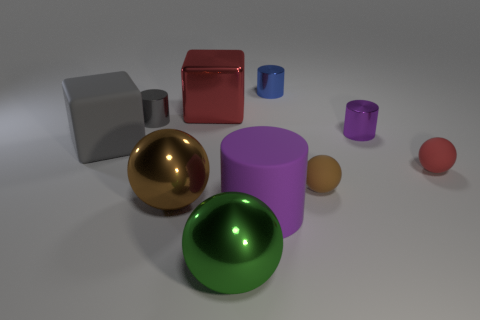Subtract all big brown metallic spheres. How many spheres are left? 3 Subtract all cubes. How many objects are left? 8 Subtract 1 blue cylinders. How many objects are left? 9 Subtract all large blue matte blocks. Subtract all gray matte things. How many objects are left? 9 Add 4 large cylinders. How many large cylinders are left? 5 Add 6 large rubber cylinders. How many large rubber cylinders exist? 7 